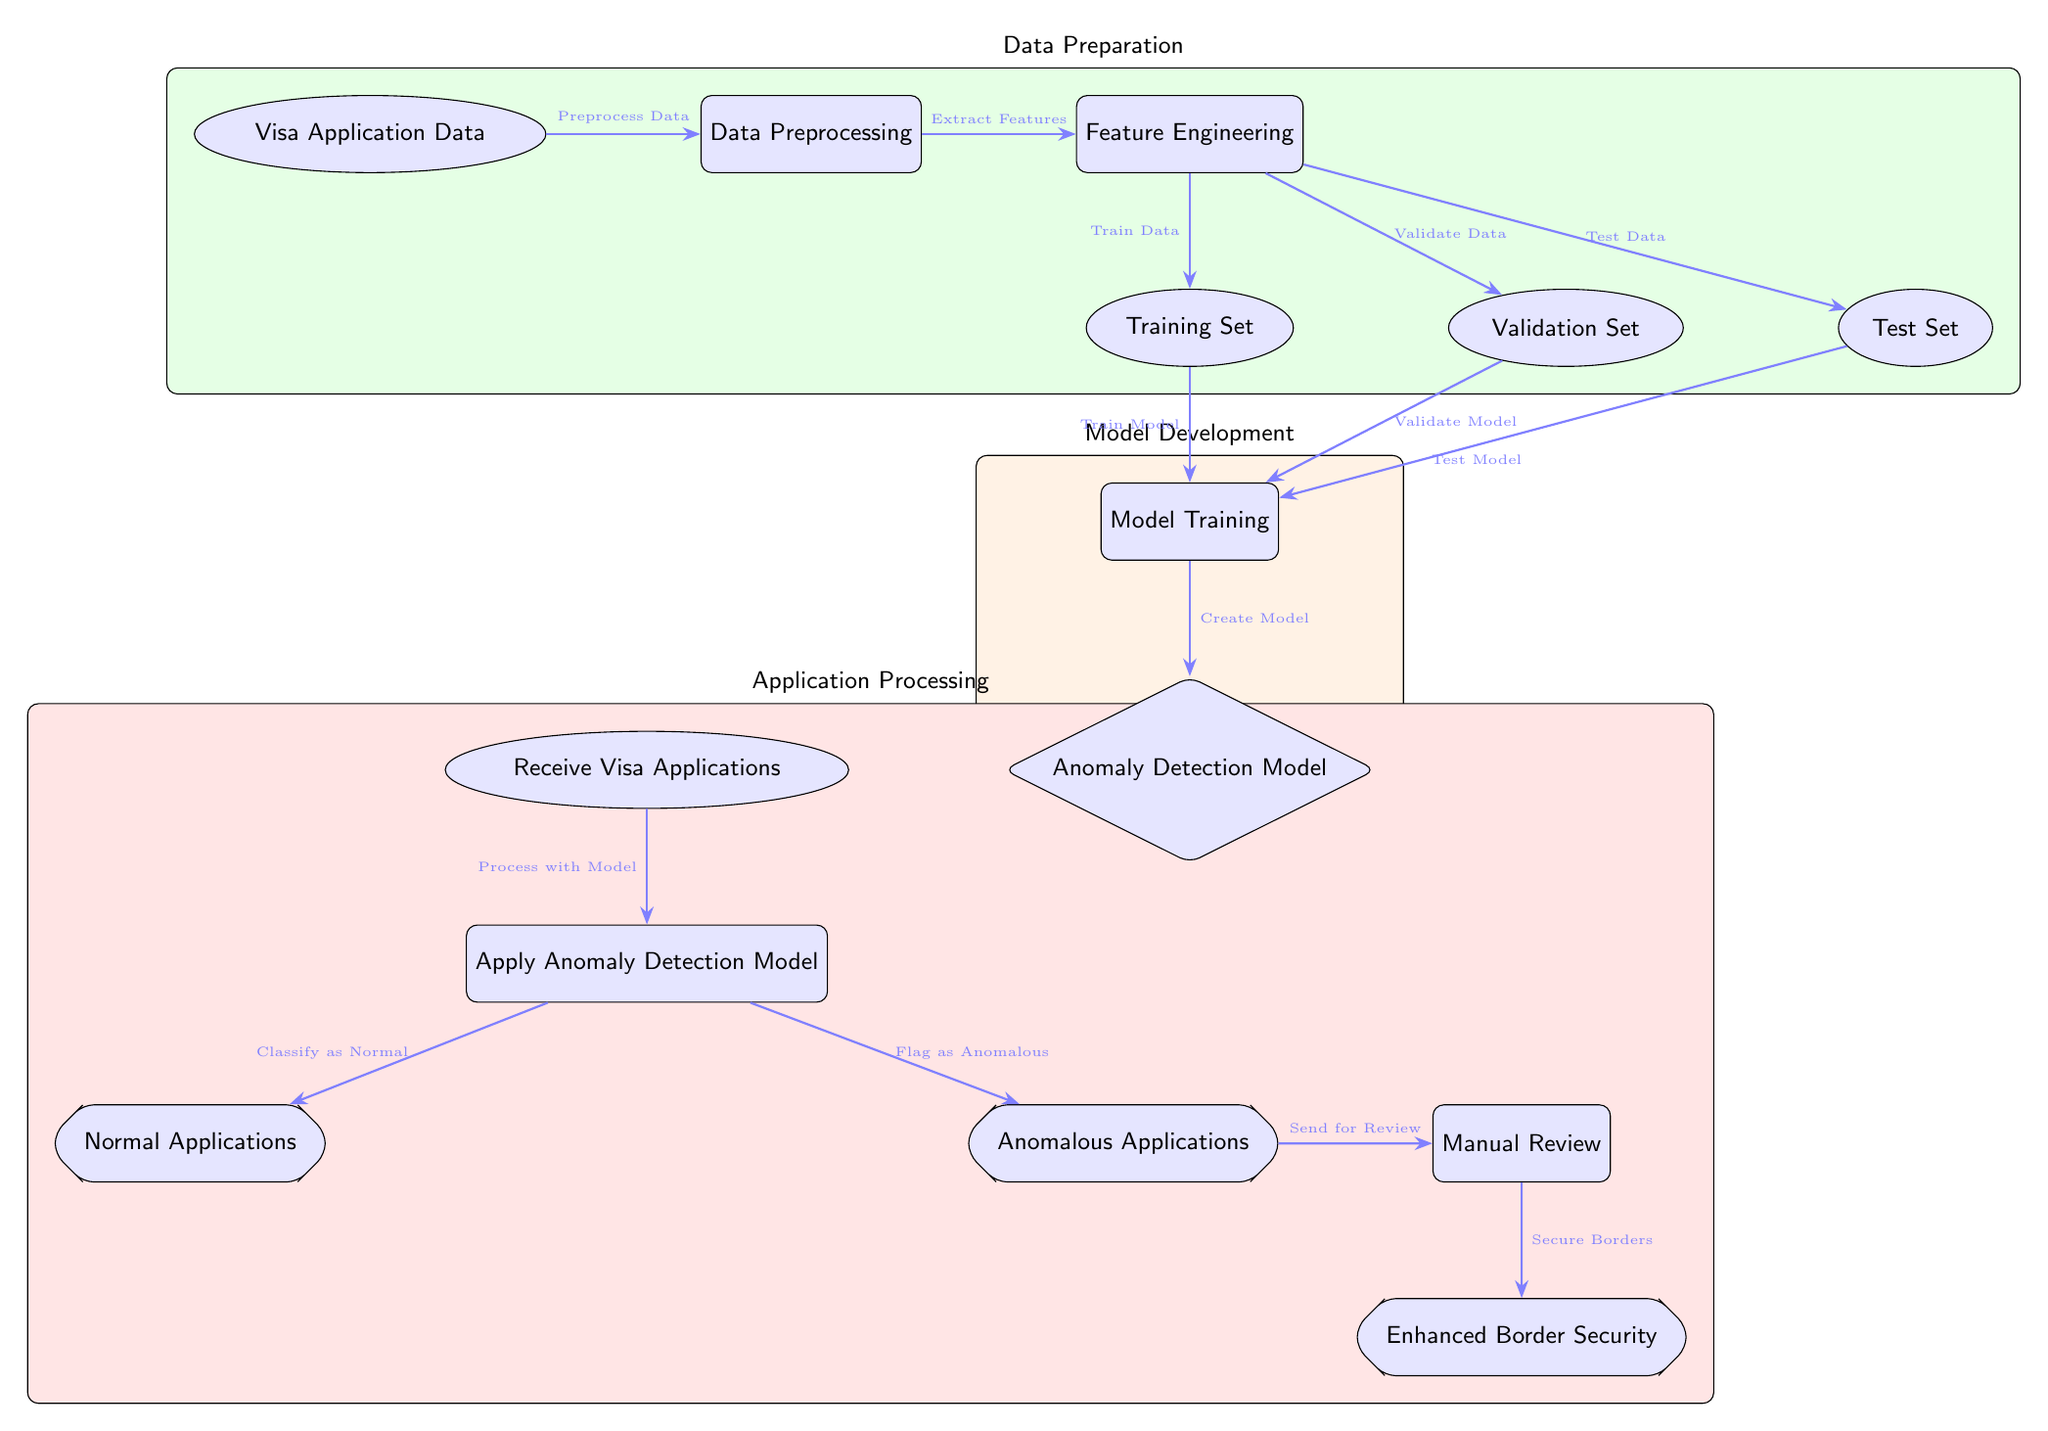What is the first node in the diagram? The first node in the diagram is labeled "Visa Application Data." It is the starting point from which all processes emanate.
Answer: Visa Application Data How many sets of data are defined in the diagram? The diagram indicates three sets of data: Training Set, Validation Set, and Test Set. Each one represents a different phase in the model's lifecycle.
Answer: 3 What process occurs immediately after data preprocessing? After data preprocessing, the next process is "Feature Engineering." This step involves extracting relevant features from the preprocessed data.
Answer: Feature Engineering What are the outputs of the Anomaly Detection Model? The outputs of the Anomaly Detection Model are "Normal Applications" and "Anomalous Applications," showing the classification results of the model.
Answer: Normal Applications, Anomalous Applications What is the final step in the diagram? The final step in the diagram is "Enhanced Border Security." This occurs after the manual review process of anomalous applications, which aims to improve security measures.
Answer: Enhanced Border Security How are applications classified in the diagram? Applications are classified using the "Apply Anomaly Detection Model," which categorizes them into either normal or anomalous based on the model’s output.
Answer: Normal or Anomalous What action follows the classification of applications as anomalous? The action that follows the classification of applications as anomalous is "Manual Review," where flagged applications undergo a detailed examination.
Answer: Manual Review Which color represents the Application Processing phase in the diagram? The Application Processing phase is represented in red. This color signifies the set of tasks related to processing visa applications after detection.
Answer: Red What three processes are included under the Model Development section? The three processes included under the Model Development section are "Model Training," "Anomaly Detection Model," and the relationships between training into model creation and validation.
Answer: Model Training, Anomaly Detection Model What does the arrow indicate between the "Manual Review" and "Enhanced Border Security"? The arrow indicates that the output of the "Manual Review" process contributes to "Enhanced Border Security," representing the flow of information necessary for security improvements.
Answer: Flow of information 